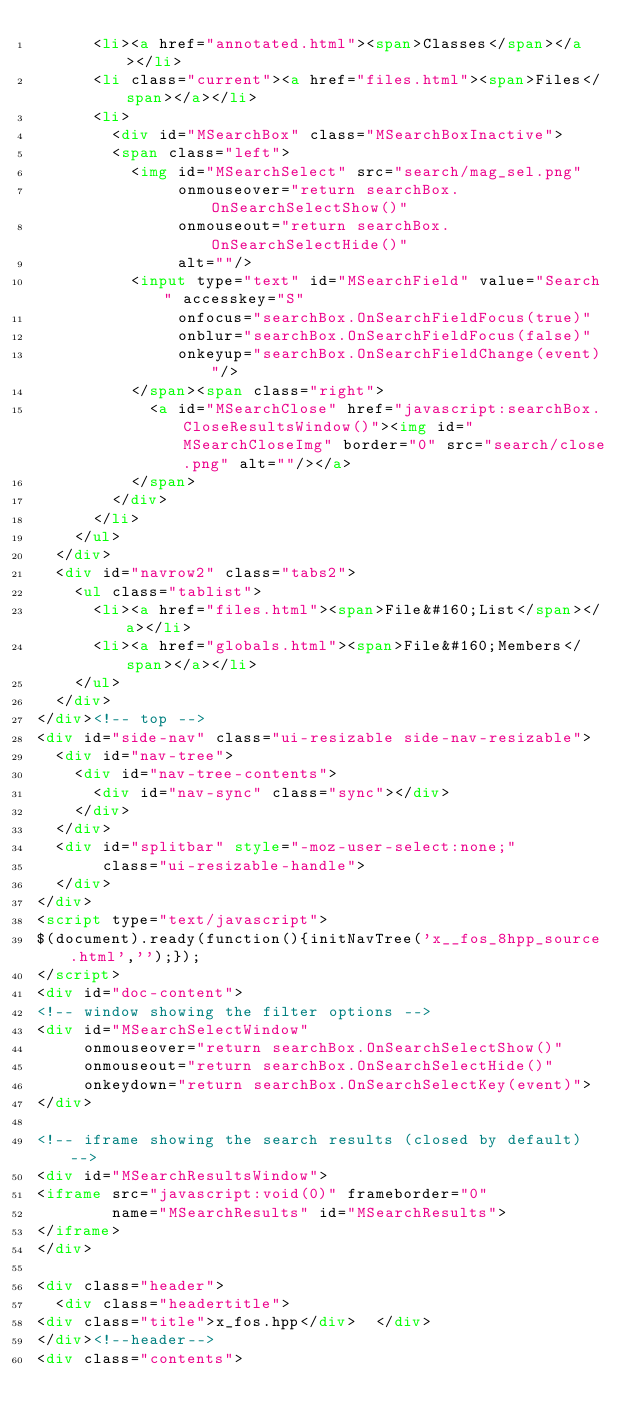Convert code to text. <code><loc_0><loc_0><loc_500><loc_500><_HTML_>      <li><a href="annotated.html"><span>Classes</span></a></li>
      <li class="current"><a href="files.html"><span>Files</span></a></li>
      <li>
        <div id="MSearchBox" class="MSearchBoxInactive">
        <span class="left">
          <img id="MSearchSelect" src="search/mag_sel.png"
               onmouseover="return searchBox.OnSearchSelectShow()"
               onmouseout="return searchBox.OnSearchSelectHide()"
               alt=""/>
          <input type="text" id="MSearchField" value="Search" accesskey="S"
               onfocus="searchBox.OnSearchFieldFocus(true)" 
               onblur="searchBox.OnSearchFieldFocus(false)" 
               onkeyup="searchBox.OnSearchFieldChange(event)"/>
          </span><span class="right">
            <a id="MSearchClose" href="javascript:searchBox.CloseResultsWindow()"><img id="MSearchCloseImg" border="0" src="search/close.png" alt=""/></a>
          </span>
        </div>
      </li>
    </ul>
  </div>
  <div id="navrow2" class="tabs2">
    <ul class="tablist">
      <li><a href="files.html"><span>File&#160;List</span></a></li>
      <li><a href="globals.html"><span>File&#160;Members</span></a></li>
    </ul>
  </div>
</div><!-- top -->
<div id="side-nav" class="ui-resizable side-nav-resizable">
  <div id="nav-tree">
    <div id="nav-tree-contents">
      <div id="nav-sync" class="sync"></div>
    </div>
  </div>
  <div id="splitbar" style="-moz-user-select:none;" 
       class="ui-resizable-handle">
  </div>
</div>
<script type="text/javascript">
$(document).ready(function(){initNavTree('x__fos_8hpp_source.html','');});
</script>
<div id="doc-content">
<!-- window showing the filter options -->
<div id="MSearchSelectWindow"
     onmouseover="return searchBox.OnSearchSelectShow()"
     onmouseout="return searchBox.OnSearchSelectHide()"
     onkeydown="return searchBox.OnSearchSelectKey(event)">
</div>

<!-- iframe showing the search results (closed by default) -->
<div id="MSearchResultsWindow">
<iframe src="javascript:void(0)" frameborder="0" 
        name="MSearchResults" id="MSearchResults">
</iframe>
</div>

<div class="header">
  <div class="headertitle">
<div class="title">x_fos.hpp</div>  </div>
</div><!--header-->
<div class="contents"></code> 